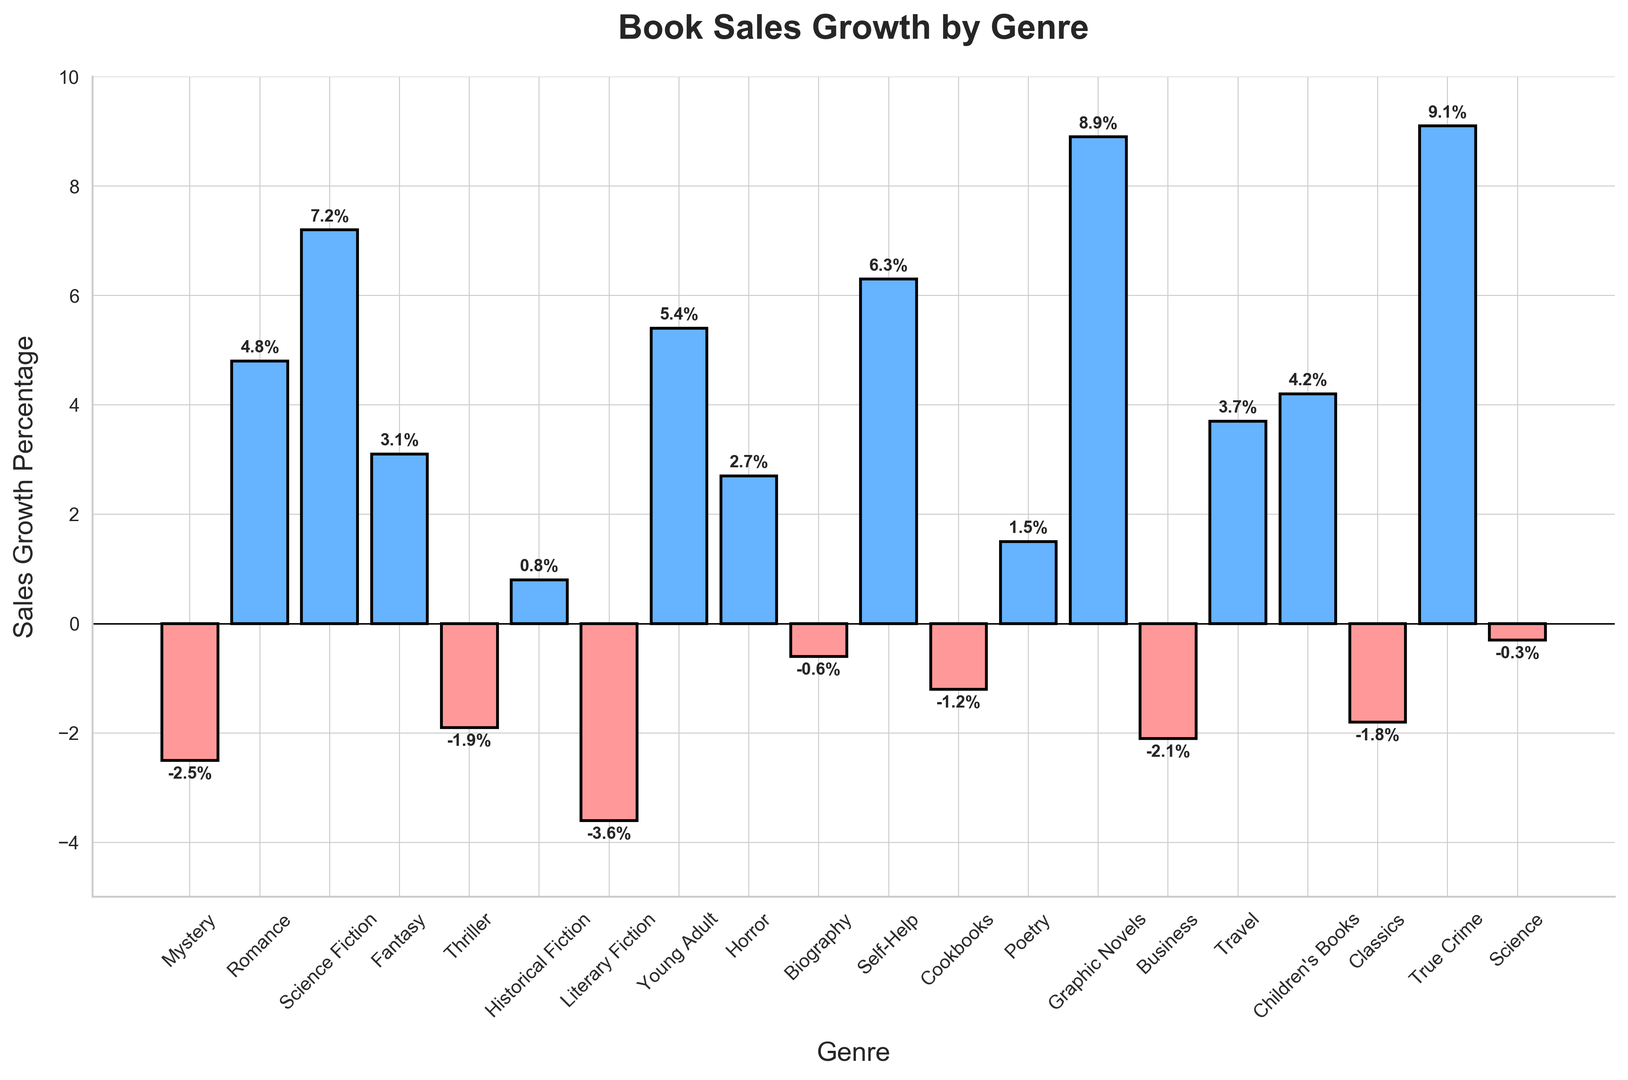Which genre experienced the highest book sales growth according to the chart? Look for the tallest bar in the chart. The genre with the highest sales growth is represented by the tallest bar.
Answer: True Crime Which genre had a negative sales growth and the largest magnitude of decline? Identify the genres with red bars (indicating negative growth). Among these, find the shortest bar (largest negative value).
Answer: Literary Fiction What's the difference in sales growth between Science Fiction and Mystery genres? Locate the heights of the bars for Science Fiction (7.2%) and Mystery (-2.5%). Calculate the difference: 7.2 - (-2.5) = 7.2 + 2.5
Answer: 9.7 Of the genres with positive sales growth, which genre had the smallest growth? Focus on blue bars (positive growth). Identify the shortest blue bar which represents the smallest positive growth in percentage.
Answer: Historical Fiction How many genres experienced a decline in sales growth compared to the previous year? Count the red bars (representing negative growth percentages) in the chart.
Answer: 7 What is the combined sales growth percentage of Romance, Fantasy, and Horror genres? Add the growth percentages of Romance (4.8%), Fantasy (3.1%), and Horror (2.7%): 4.8 + 3.1 + 2.7
Answer: 10.6 Which genre had the closest sales growth percentage to zero? Identify the bar that is nearest to the horizontal axis at zero.
Answer: Science Which two genres have sales growth percentages that are closest to each other? Compare the values visually to find which two bars of similar height are closest in percentage.
Answer: Mystery and Thriller What is the average sales growth percentage of the genres listed? Sum up all the percentages and divide by the number of genres. Total sum is -2.5 + 4.8 + 7.2 + 3.1 - 1.9 + 0.8 - 3.6 + 5.4 + 2.7 + -0.6 + 6.3 + -1.2 + 1.5 + 8.9 + -2.1 + 3.7 + 4.2 + -1.8 + 9.1 + -0.3 = 43.6. There are 20 genres. Average is 43.6 / 20
Answer: 2.18 What's the total positive sales growth percentage? Add only the positive growth percentages: 4.8 + 7.2 + 3.1 + 0.8 + 5.4 + 2.7 + 6.3 + 1.5 + 8.9 + 3.7 + 4.2 + 9.1 = 57.7
Answer: 57.7 